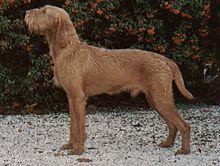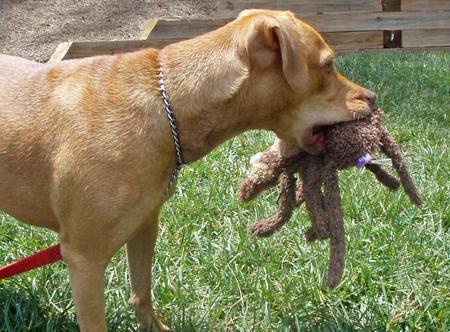The first image is the image on the left, the second image is the image on the right. For the images displayed, is the sentence "In one image, a dog is carrying a stuffed animal in its mouth." factually correct? Answer yes or no. Yes. 